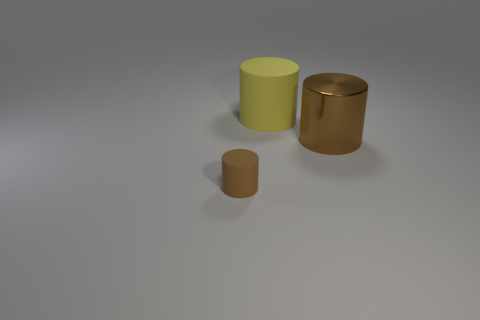There is a brown cylinder in front of the brown cylinder that is behind the rubber cylinder that is in front of the metal cylinder; what is its size?
Provide a succinct answer. Small. Are there the same number of large yellow things that are to the left of the yellow cylinder and brown things?
Provide a succinct answer. No. Does the small object have the same shape as the big thing that is on the right side of the yellow rubber object?
Make the answer very short. Yes. There is another brown thing that is the same shape as the metallic thing; what size is it?
Provide a short and direct response. Small. What number of other things are the same material as the tiny cylinder?
Give a very brief answer. 1. What material is the tiny thing?
Your answer should be very brief. Rubber. Do the big metal cylinder behind the tiny brown thing and the rubber object that is in front of the brown shiny cylinder have the same color?
Your response must be concise. Yes. Is the number of cylinders that are in front of the small rubber cylinder greater than the number of big metal cylinders?
Make the answer very short. No. How many other objects are there of the same color as the small thing?
Your response must be concise. 1. Do the brown object in front of the brown metal thing and the large yellow rubber thing have the same size?
Keep it short and to the point. No. 